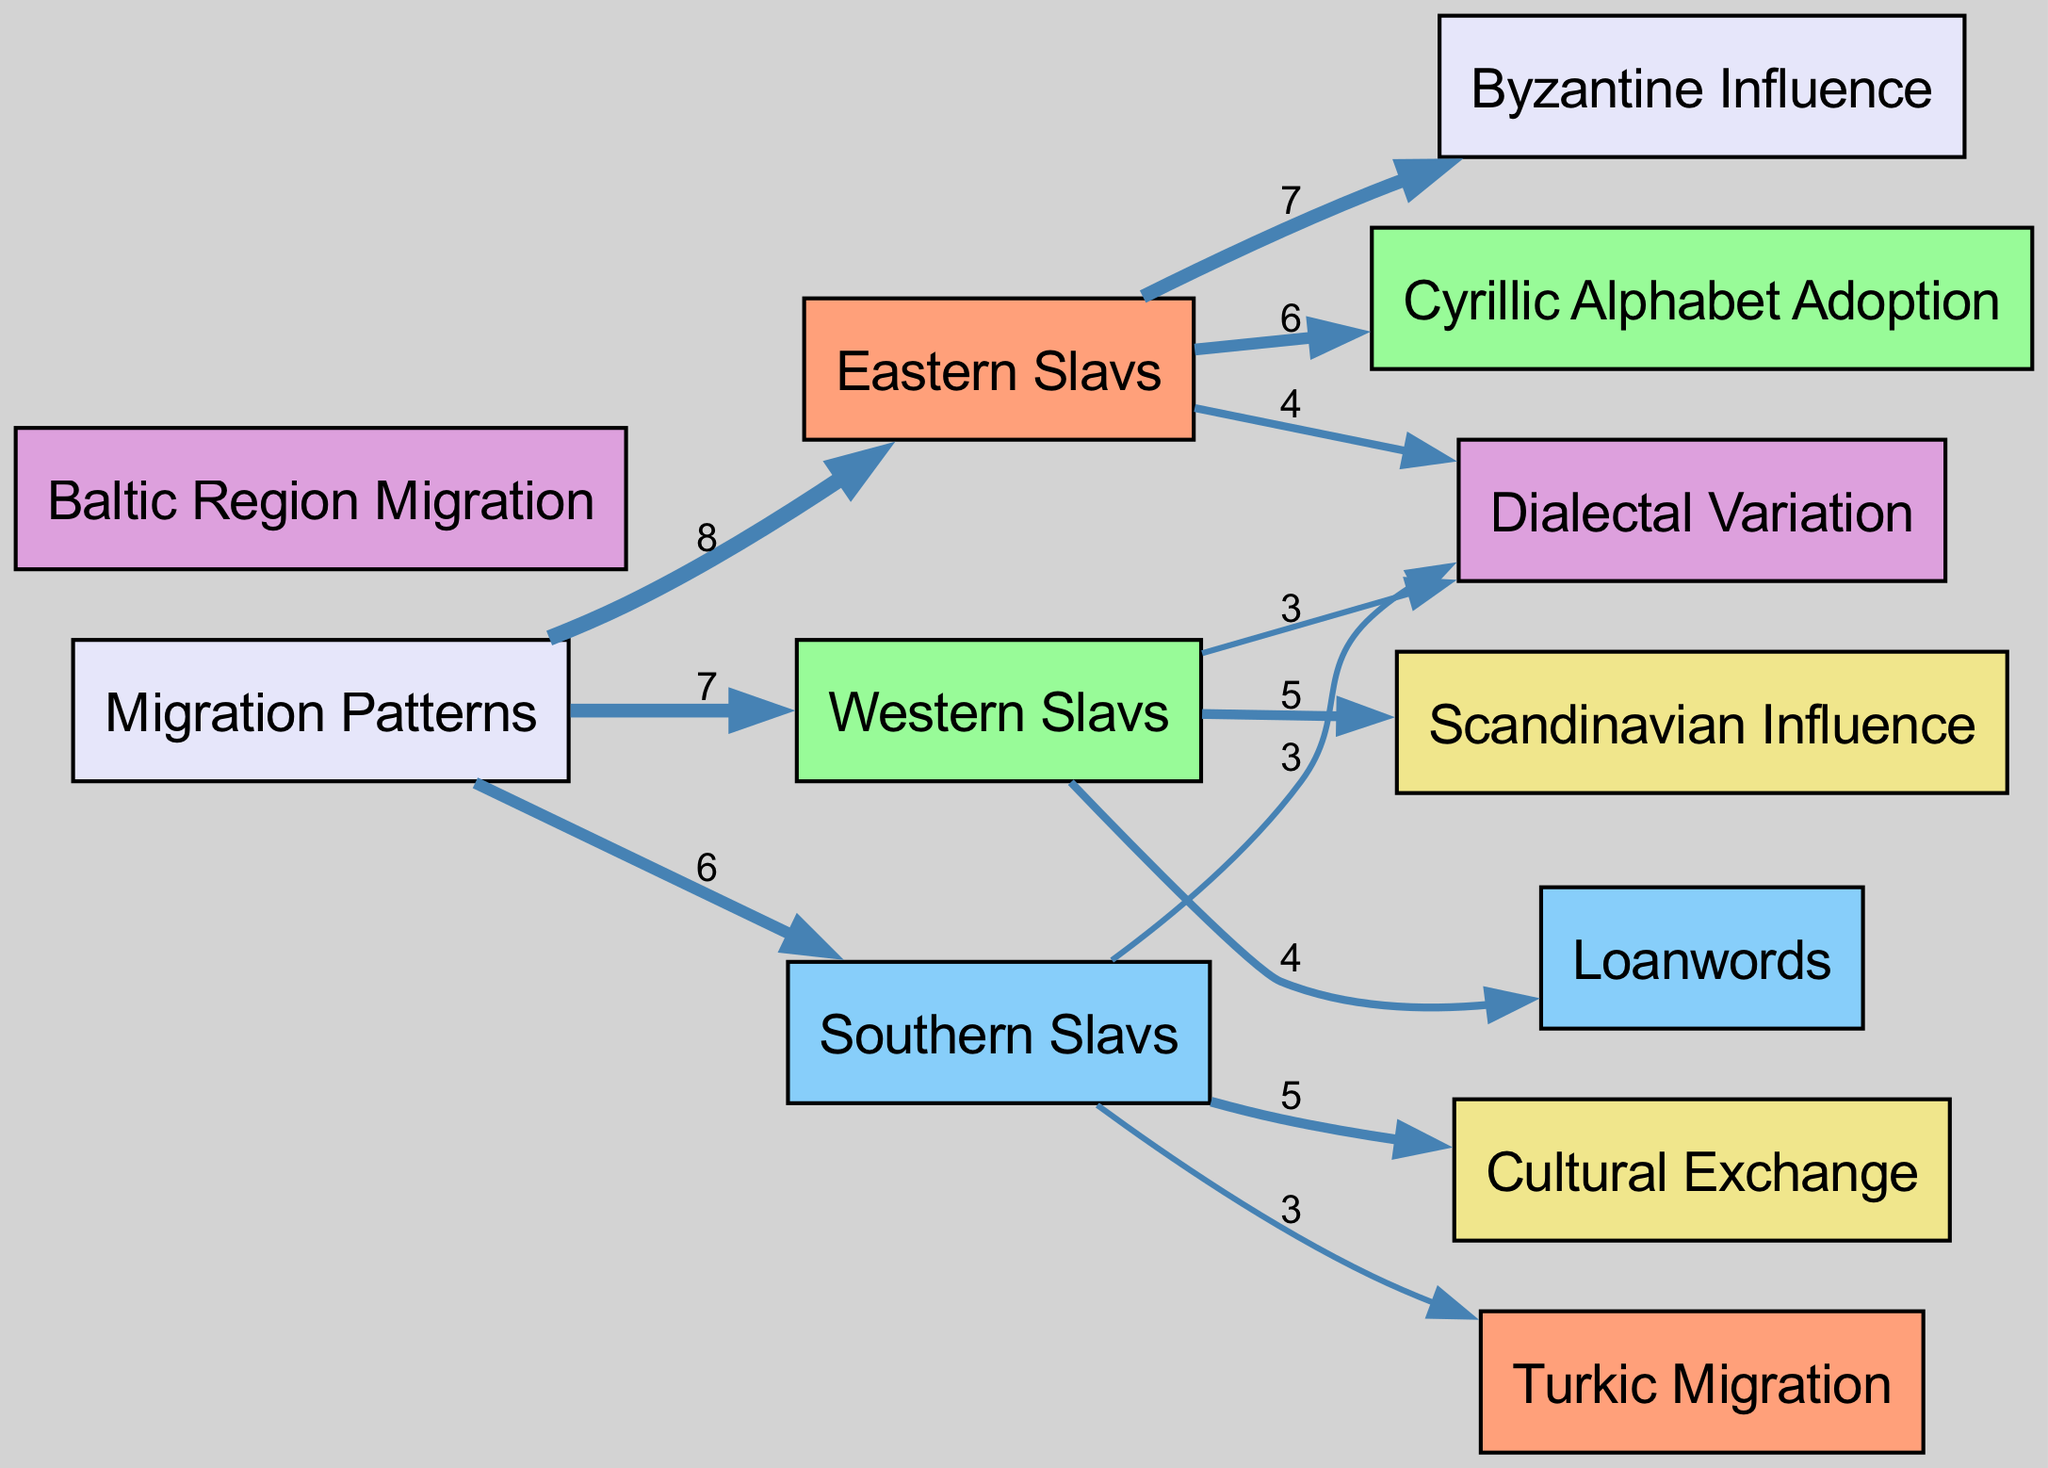What is the total number of nodes in the diagram? The diagram includes a list of nodes. By counting the number of unique entries in the "nodes" data, we find that there are 12 individual nodes present.
Answer: 12 Which Slavic group has the highest influence from Byzantine culture? In the diagram, the link from "Eastern Slavs" to "Byzantine Influence" has the highest value of 7, indicating a significant influence.
Answer: 7 What is the value of the link from Western Slavs to Loanwords? The diagram shows that the link from "Western Slavs" to "Loanwords" has a value of 4, which represents the amount of influence.
Answer: 4 How many links are there connecting to Southern Slavs? By inspecting the "links" data connected to "Southern Slavs," we see three separate connections, allowing us to conclude that there are 3 links in total.
Answer: 3 Which migration pattern contributes to the highest influence on Eastern Slavs? The link showing the highest value influencing "Eastern Slavs" is the one connecting to "Byzantine Influence," with a value of 7, indicating it has the most significant contribution.
Answer: Byzantine Influence How many factors influence Western Slavs compared to Eastern Slavs? Western Slavs are influenced by 3 different factors (links) shown in the diagram, while Eastern Slavs have 4 links. This comparison reveals that Eastern Slavs have one more influencing factor than Western Slavs.
Answer: Eastern Slavs have 4 and Western Slavs have 3 Which Slavic speaker group has the lowest connection to Dialectal Variation? The "Southern Slavs" group is connected to "Dialectal Variation" with a value of 3, which is the lowest when compared to "Eastern Slavs" (4) and "Western Slavs" (3). However, since both Western and Southern Slavs have the same value, this indicates they are equally low.
Answer: Southern Slavs What does the value 8 represent in the diagram? The value 8 represents the total influence of the migration patterns specifically directed toward "Eastern Slavs," indicating the strength of that migration flow.
Answer: 8 Which Slavic group exhibits a strong relationship with cultural exchange? The link from "Southern Slavs" to "Cultural Exchange" has a value of 5, indicating a strong relationship compared to other groups.
Answer: 5 What is the significance of Turkic Migration for Southern Slavs? The diagram shows a link from "Southern Slavs" to "Turkic Migration" with a value of 3, highlighting its significance as an influencing factor, albeit relatively lower compared to others.
Answer: 3 